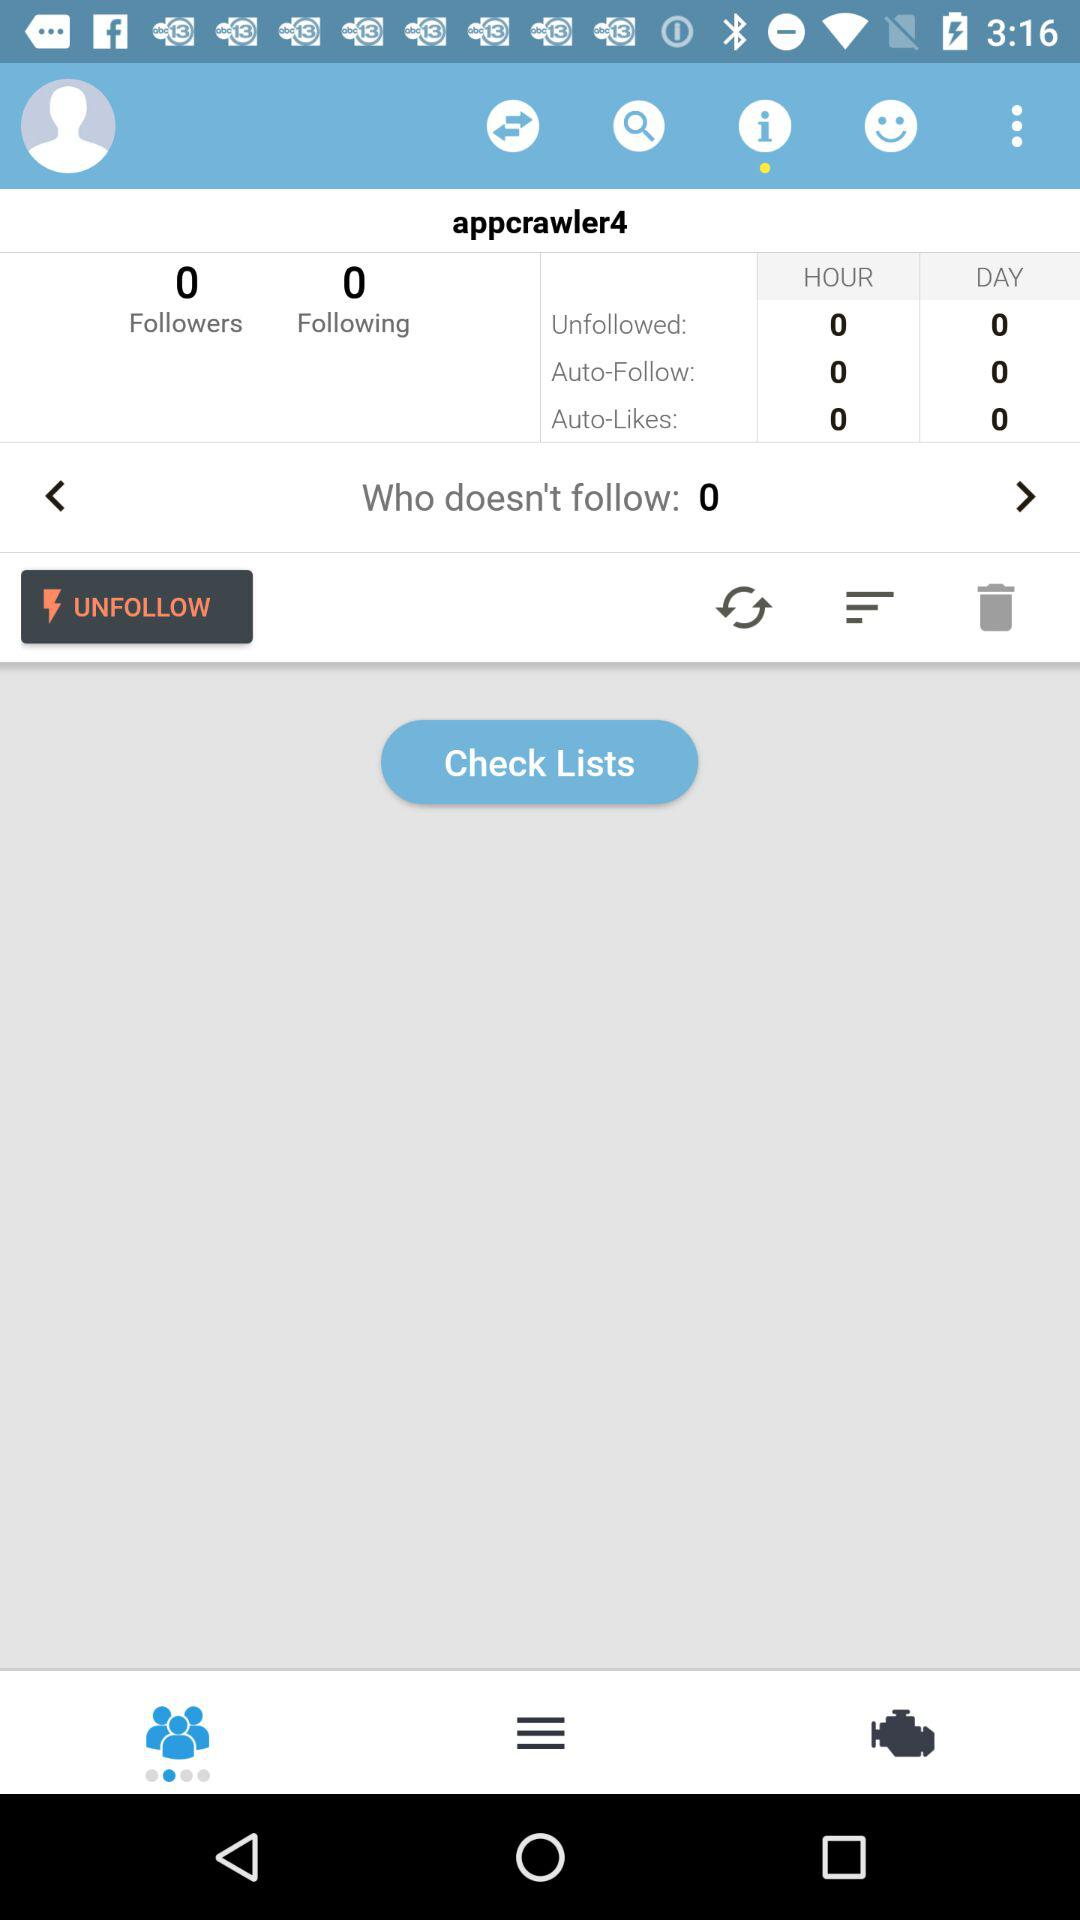How many followers are there? There are 0 followers. 